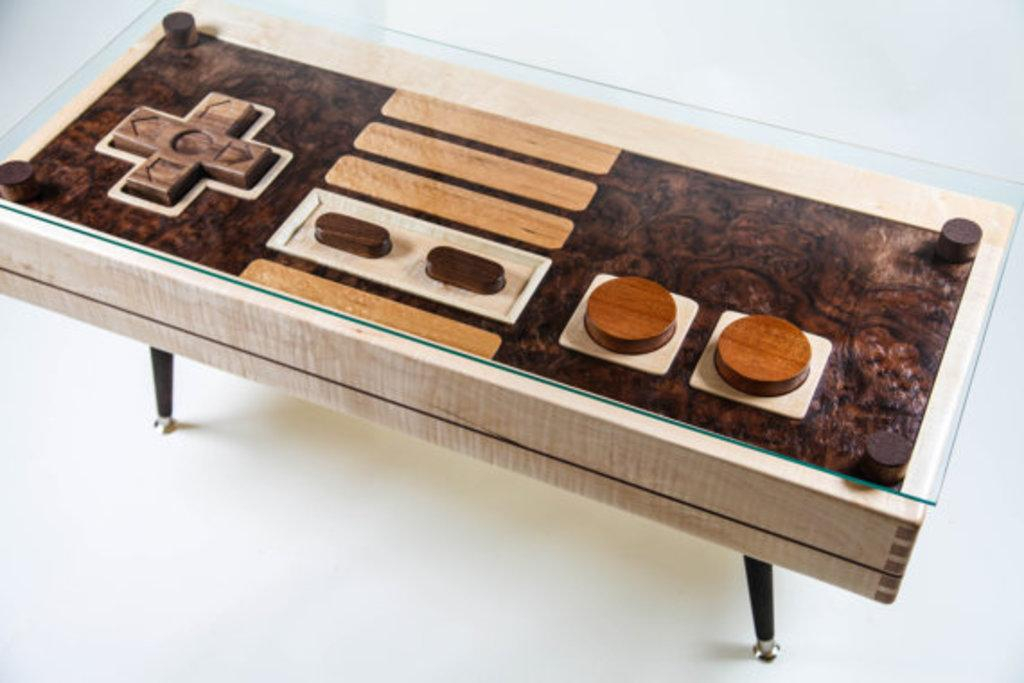What is the main object in the image? There is a table in the image. Can you describe the positioning of the table? The table is placed on a surface. What type of shoe is visible on the table in the image? There is no shoe present on the table in the image. What list of items can be seen on the table in the image? There is no list of items present on the table in the image. What type of soup is being served on the table in the image? There is no soup present on the table in the image. 